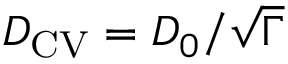Convert formula to latex. <formula><loc_0><loc_0><loc_500><loc_500>D _ { C V } = D _ { 0 } / \sqrt { \Gamma }</formula> 